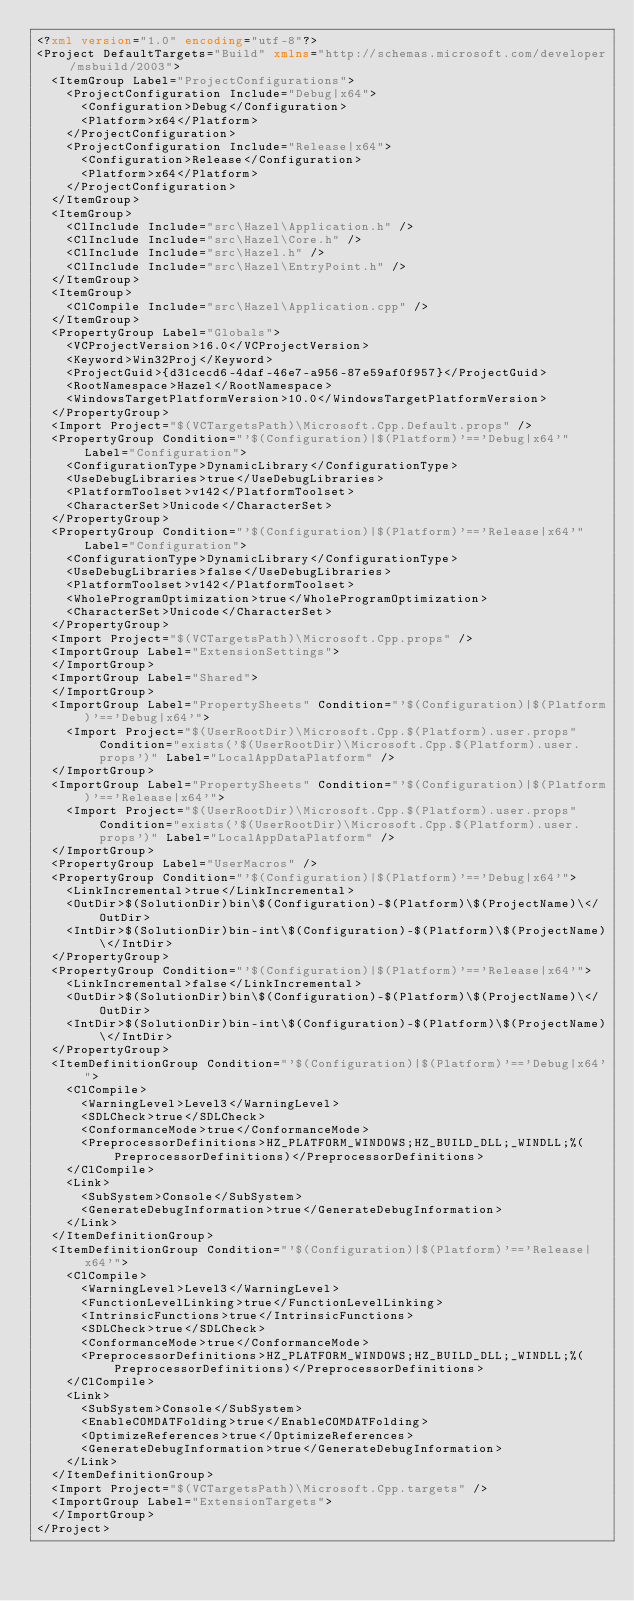<code> <loc_0><loc_0><loc_500><loc_500><_XML_><?xml version="1.0" encoding="utf-8"?>
<Project DefaultTargets="Build" xmlns="http://schemas.microsoft.com/developer/msbuild/2003">
  <ItemGroup Label="ProjectConfigurations">
    <ProjectConfiguration Include="Debug|x64">
      <Configuration>Debug</Configuration>
      <Platform>x64</Platform>
    </ProjectConfiguration>
    <ProjectConfiguration Include="Release|x64">
      <Configuration>Release</Configuration>
      <Platform>x64</Platform>
    </ProjectConfiguration>
  </ItemGroup>
  <ItemGroup>
    <ClInclude Include="src\Hazel\Application.h" />
    <ClInclude Include="src\Hazel\Core.h" />
    <ClInclude Include="src\Hazel.h" />
    <ClInclude Include="src\Hazel\EntryPoint.h" />
  </ItemGroup>
  <ItemGroup>
    <ClCompile Include="src\Hazel\Application.cpp" />
  </ItemGroup>
  <PropertyGroup Label="Globals">
    <VCProjectVersion>16.0</VCProjectVersion>
    <Keyword>Win32Proj</Keyword>
    <ProjectGuid>{d31cecd6-4daf-46e7-a956-87e59af0f957}</ProjectGuid>
    <RootNamespace>Hazel</RootNamespace>
    <WindowsTargetPlatformVersion>10.0</WindowsTargetPlatformVersion>
  </PropertyGroup>
  <Import Project="$(VCTargetsPath)\Microsoft.Cpp.Default.props" />
  <PropertyGroup Condition="'$(Configuration)|$(Platform)'=='Debug|x64'" Label="Configuration">
    <ConfigurationType>DynamicLibrary</ConfigurationType>
    <UseDebugLibraries>true</UseDebugLibraries>
    <PlatformToolset>v142</PlatformToolset>
    <CharacterSet>Unicode</CharacterSet>
  </PropertyGroup>
  <PropertyGroup Condition="'$(Configuration)|$(Platform)'=='Release|x64'" Label="Configuration">
    <ConfigurationType>DynamicLibrary</ConfigurationType>
    <UseDebugLibraries>false</UseDebugLibraries>
    <PlatformToolset>v142</PlatformToolset>
    <WholeProgramOptimization>true</WholeProgramOptimization>
    <CharacterSet>Unicode</CharacterSet>
  </PropertyGroup>
  <Import Project="$(VCTargetsPath)\Microsoft.Cpp.props" />
  <ImportGroup Label="ExtensionSettings">
  </ImportGroup>
  <ImportGroup Label="Shared">
  </ImportGroup>
  <ImportGroup Label="PropertySheets" Condition="'$(Configuration)|$(Platform)'=='Debug|x64'">
    <Import Project="$(UserRootDir)\Microsoft.Cpp.$(Platform).user.props" Condition="exists('$(UserRootDir)\Microsoft.Cpp.$(Platform).user.props')" Label="LocalAppDataPlatform" />
  </ImportGroup>
  <ImportGroup Label="PropertySheets" Condition="'$(Configuration)|$(Platform)'=='Release|x64'">
    <Import Project="$(UserRootDir)\Microsoft.Cpp.$(Platform).user.props" Condition="exists('$(UserRootDir)\Microsoft.Cpp.$(Platform).user.props')" Label="LocalAppDataPlatform" />
  </ImportGroup>
  <PropertyGroup Label="UserMacros" />
  <PropertyGroup Condition="'$(Configuration)|$(Platform)'=='Debug|x64'">
    <LinkIncremental>true</LinkIncremental>
    <OutDir>$(SolutionDir)bin\$(Configuration)-$(Platform)\$(ProjectName)\</OutDir>
    <IntDir>$(SolutionDir)bin-int\$(Configuration)-$(Platform)\$(ProjectName)\</IntDir>
  </PropertyGroup>
  <PropertyGroup Condition="'$(Configuration)|$(Platform)'=='Release|x64'">
    <LinkIncremental>false</LinkIncremental>
    <OutDir>$(SolutionDir)bin\$(Configuration)-$(Platform)\$(ProjectName)\</OutDir>
    <IntDir>$(SolutionDir)bin-int\$(Configuration)-$(Platform)\$(ProjectName)\</IntDir>
  </PropertyGroup>
  <ItemDefinitionGroup Condition="'$(Configuration)|$(Platform)'=='Debug|x64'">
    <ClCompile>
      <WarningLevel>Level3</WarningLevel>
      <SDLCheck>true</SDLCheck>
      <ConformanceMode>true</ConformanceMode>
      <PreprocessorDefinitions>HZ_PLATFORM_WINDOWS;HZ_BUILD_DLL;_WINDLL;%(PreprocessorDefinitions)</PreprocessorDefinitions>
    </ClCompile>
    <Link>
      <SubSystem>Console</SubSystem>
      <GenerateDebugInformation>true</GenerateDebugInformation>
    </Link>
  </ItemDefinitionGroup>
  <ItemDefinitionGroup Condition="'$(Configuration)|$(Platform)'=='Release|x64'">
    <ClCompile>
      <WarningLevel>Level3</WarningLevel>
      <FunctionLevelLinking>true</FunctionLevelLinking>
      <IntrinsicFunctions>true</IntrinsicFunctions>
      <SDLCheck>true</SDLCheck>
      <ConformanceMode>true</ConformanceMode>
      <PreprocessorDefinitions>HZ_PLATFORM_WINDOWS;HZ_BUILD_DLL;_WINDLL;%(PreprocessorDefinitions)</PreprocessorDefinitions>
    </ClCompile>
    <Link>
      <SubSystem>Console</SubSystem>
      <EnableCOMDATFolding>true</EnableCOMDATFolding>
      <OptimizeReferences>true</OptimizeReferences>
      <GenerateDebugInformation>true</GenerateDebugInformation>
    </Link>
  </ItemDefinitionGroup>
  <Import Project="$(VCTargetsPath)\Microsoft.Cpp.targets" />
  <ImportGroup Label="ExtensionTargets">
  </ImportGroup>
</Project></code> 